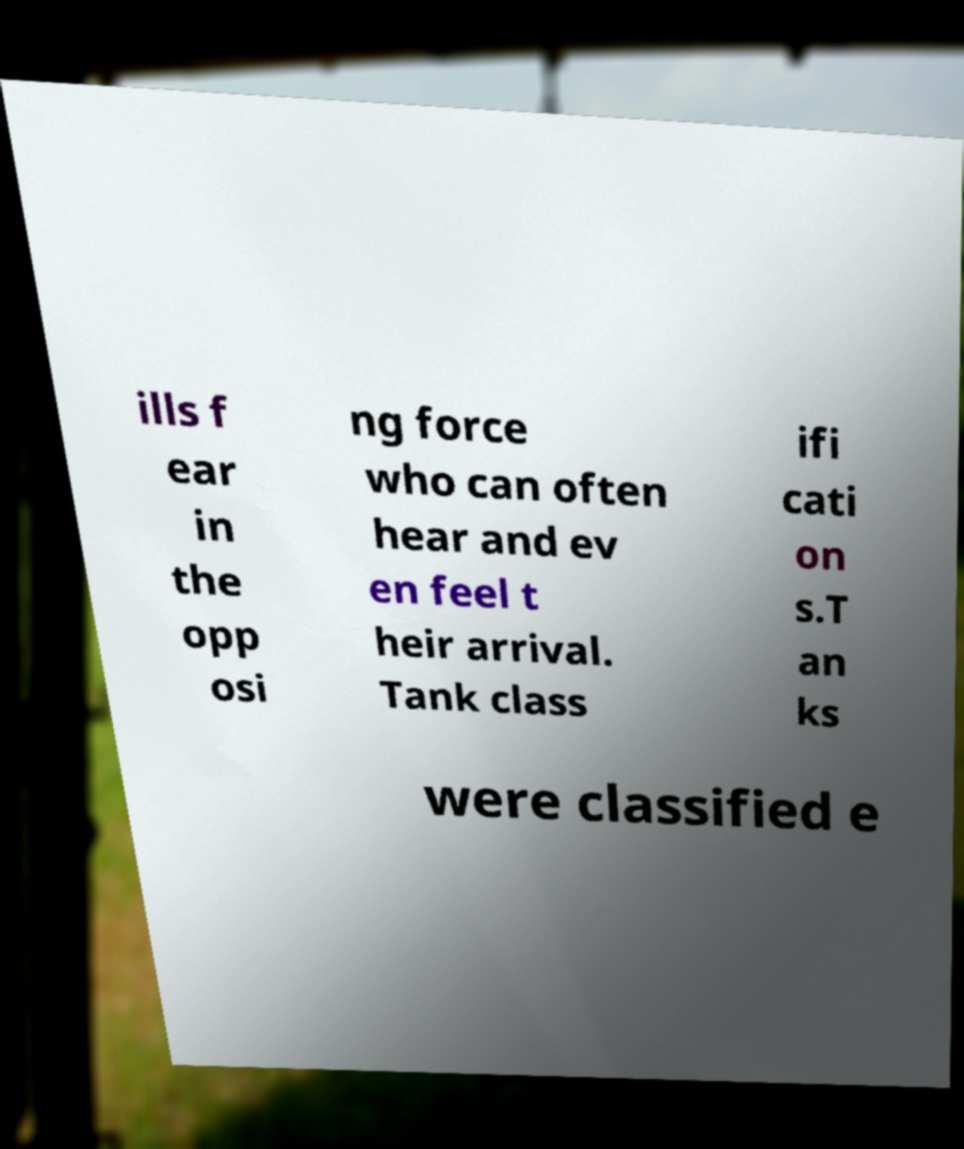Could you assist in decoding the text presented in this image and type it out clearly? ills f ear in the opp osi ng force who can often hear and ev en feel t heir arrival. Tank class ifi cati on s.T an ks were classified e 